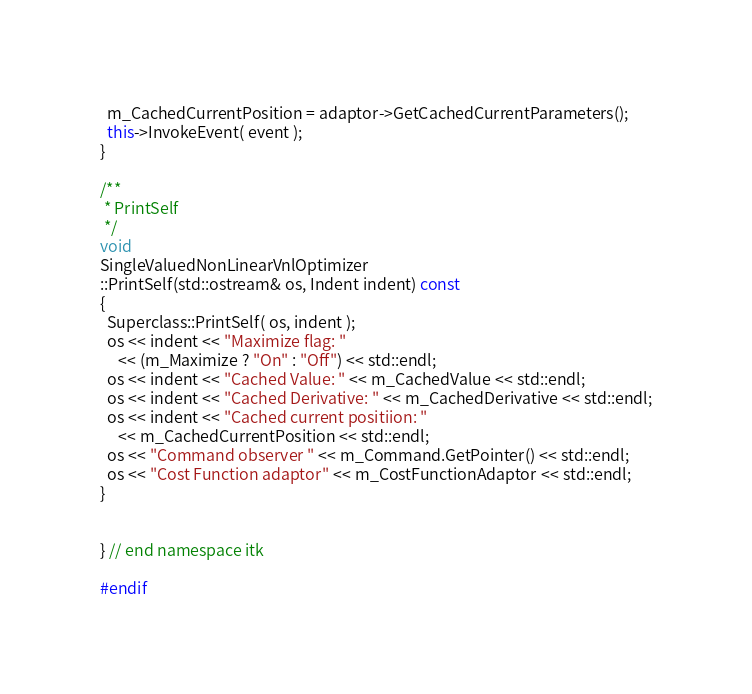<code> <loc_0><loc_0><loc_500><loc_500><_C++_>  m_CachedCurrentPosition = adaptor->GetCachedCurrentParameters();
  this->InvokeEvent( event );
}

/**
 * PrintSelf
 */
void
SingleValuedNonLinearVnlOptimizer
::PrintSelf(std::ostream& os, Indent indent) const
{
  Superclass::PrintSelf( os, indent );
  os << indent << "Maximize flag: "
     << (m_Maximize ? "On" : "Off") << std::endl;
  os << indent << "Cached Value: " << m_CachedValue << std::endl;
  os << indent << "Cached Derivative: " << m_CachedDerivative << std::endl;
  os << indent << "Cached current positiion: "
     << m_CachedCurrentPosition << std::endl;
  os << "Command observer " << m_Command.GetPointer() << std::endl;
  os << "Cost Function adaptor" << m_CostFunctionAdaptor << std::endl;
}


} // end namespace itk

#endif
</code> 